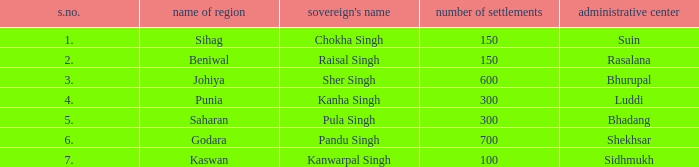What capital has an S.Number under 7, and a Name of janapada of Punia? Luddi. 